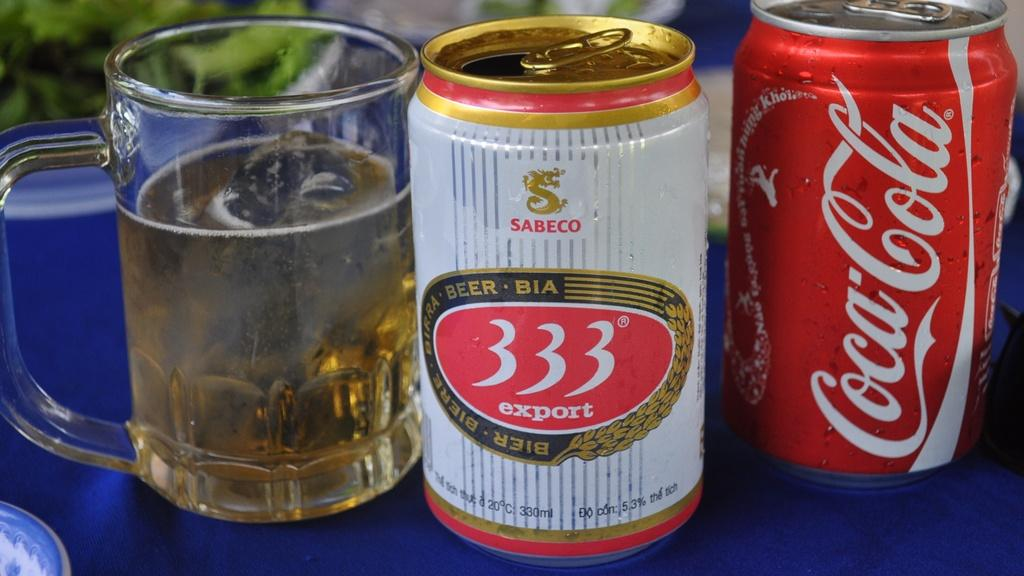<image>
Relay a brief, clear account of the picture shown. A glass filled with 333 Export beer next to its can and a can of Coca-Cola 